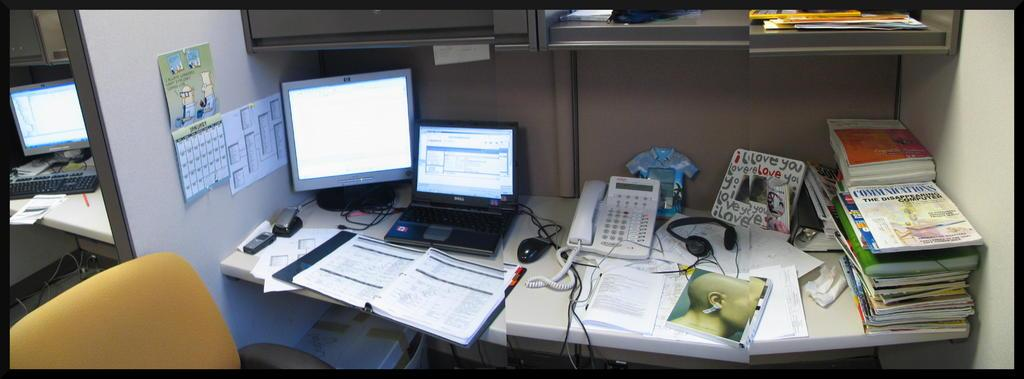What type of furniture is present in the image? There is a chair in the image. What other objects can be seen in the image? There are tables, books, papers, monitors, a telephone, a laptop, a keyboard, a mobile, a mouse, and a headset in the image. What might be used for communication in the image? There is a telephone and a mobile in the image, which can be used for communication. What might be used for input and output in the image? The keyboard, mouse, and headset in the image can be used for input and output. How many cattle are grazing on the island in the image? There are no cattle or islands present in the image. Can you see a kitty playing with a ball of yarn in the image? There is no kitty or ball of yarn present in the image. 